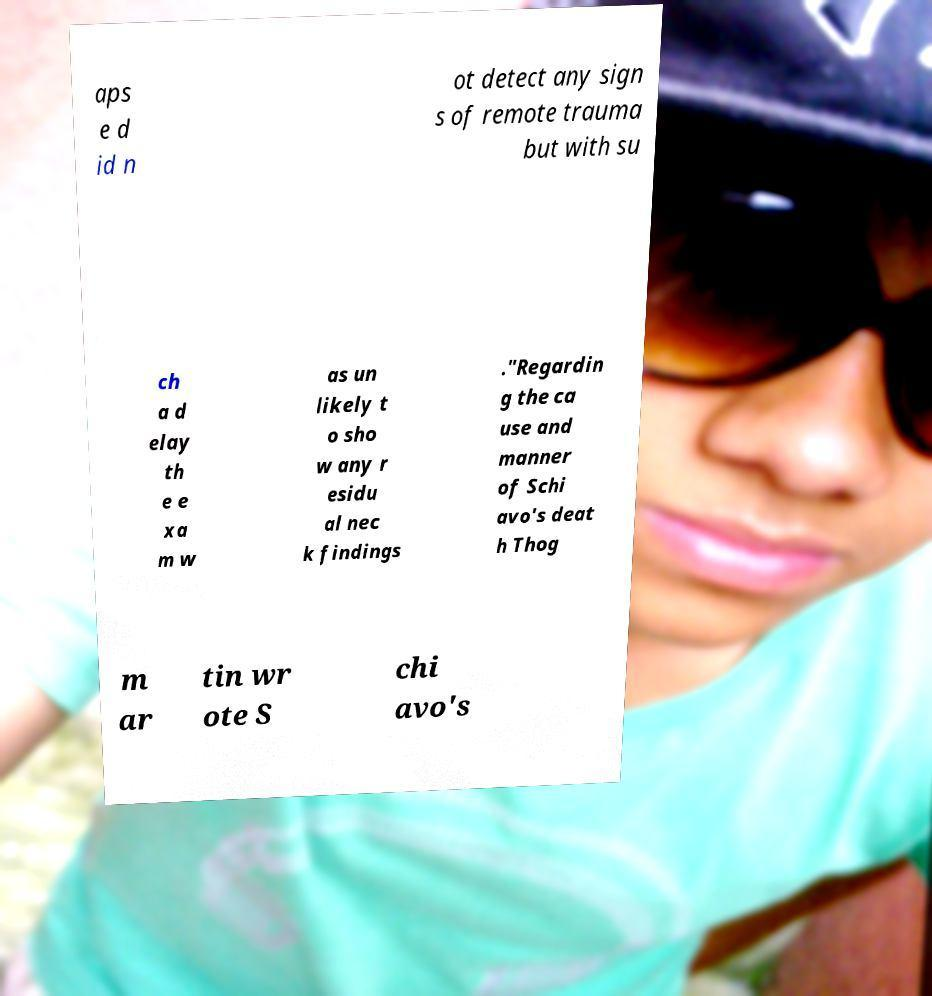There's text embedded in this image that I need extracted. Can you transcribe it verbatim? aps e d id n ot detect any sign s of remote trauma but with su ch a d elay th e e xa m w as un likely t o sho w any r esidu al nec k findings ."Regardin g the ca use and manner of Schi avo's deat h Thog m ar tin wr ote S chi avo's 